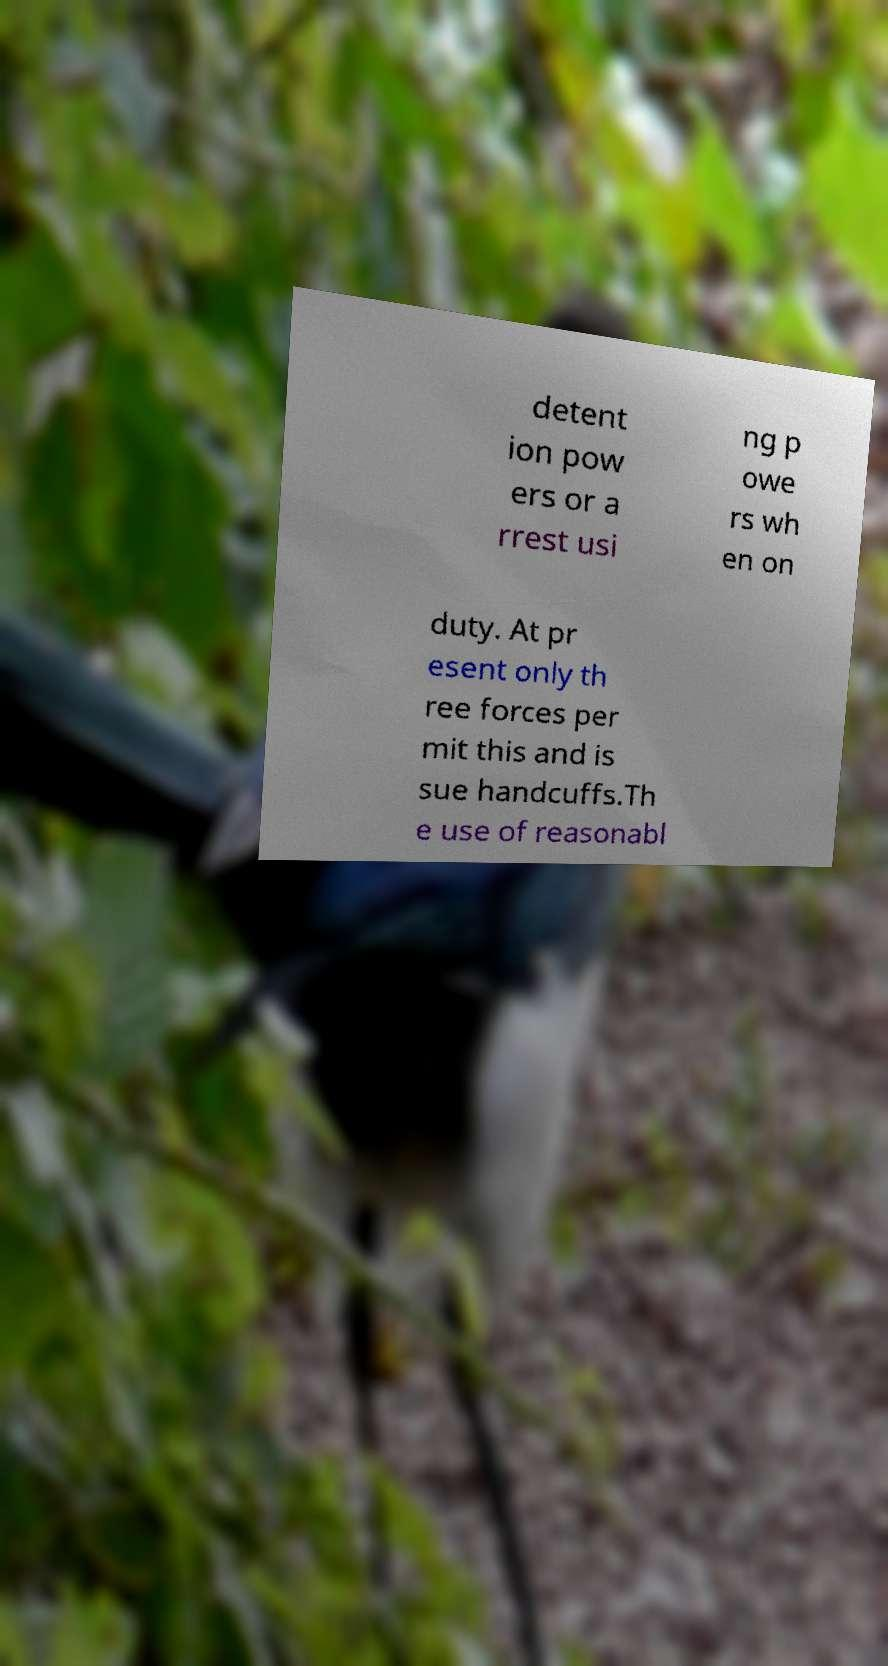Please read and relay the text visible in this image. What does it say? detent ion pow ers or a rrest usi ng p owe rs wh en on duty. At pr esent only th ree forces per mit this and is sue handcuffs.Th e use of reasonabl 